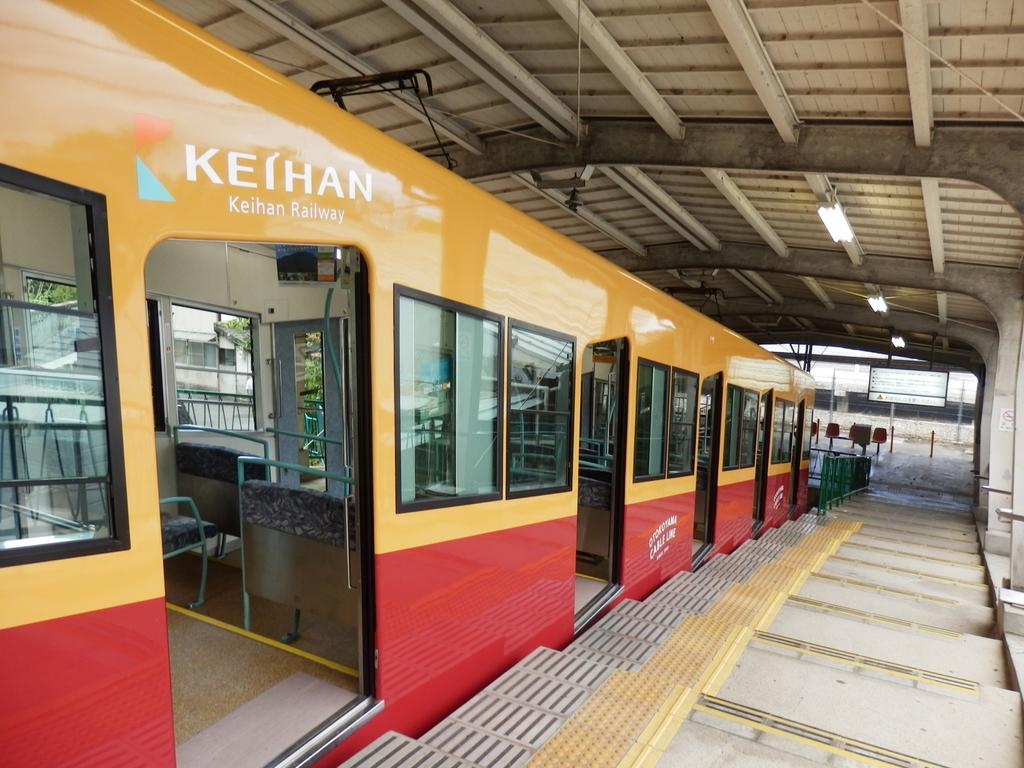What is the main subject of the image? The main subject of the image is a train. What can be found inside the train? The train has seats. What architectural feature is visible in the image? There are staircases visible in the image. What is on the roof of the train? There are lights on the roof of the train. Can you tell me how many pears are on the train in the image? There are no pears present in the image; the focus is on the train and its features. What type of room is located inside the train? There is no room visible in the image; the focus is on the train and its features. 